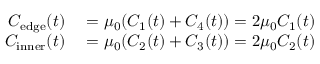Convert formula to latex. <formula><loc_0><loc_0><loc_500><loc_500>\begin{array} { r l } { C _ { e d g e } ( t ) } & = \mu _ { 0 } ( C _ { 1 } ( t ) + C _ { 4 } ( t ) ) = 2 \mu _ { 0 } C _ { 1 } ( t ) } \\ { C _ { i n n e r } ( t ) } & = \mu _ { 0 } ( C _ { 2 } ( t ) + C _ { 3 } ( t ) ) = 2 \mu _ { 0 } C _ { 2 } ( t ) } \end{array}</formula> 